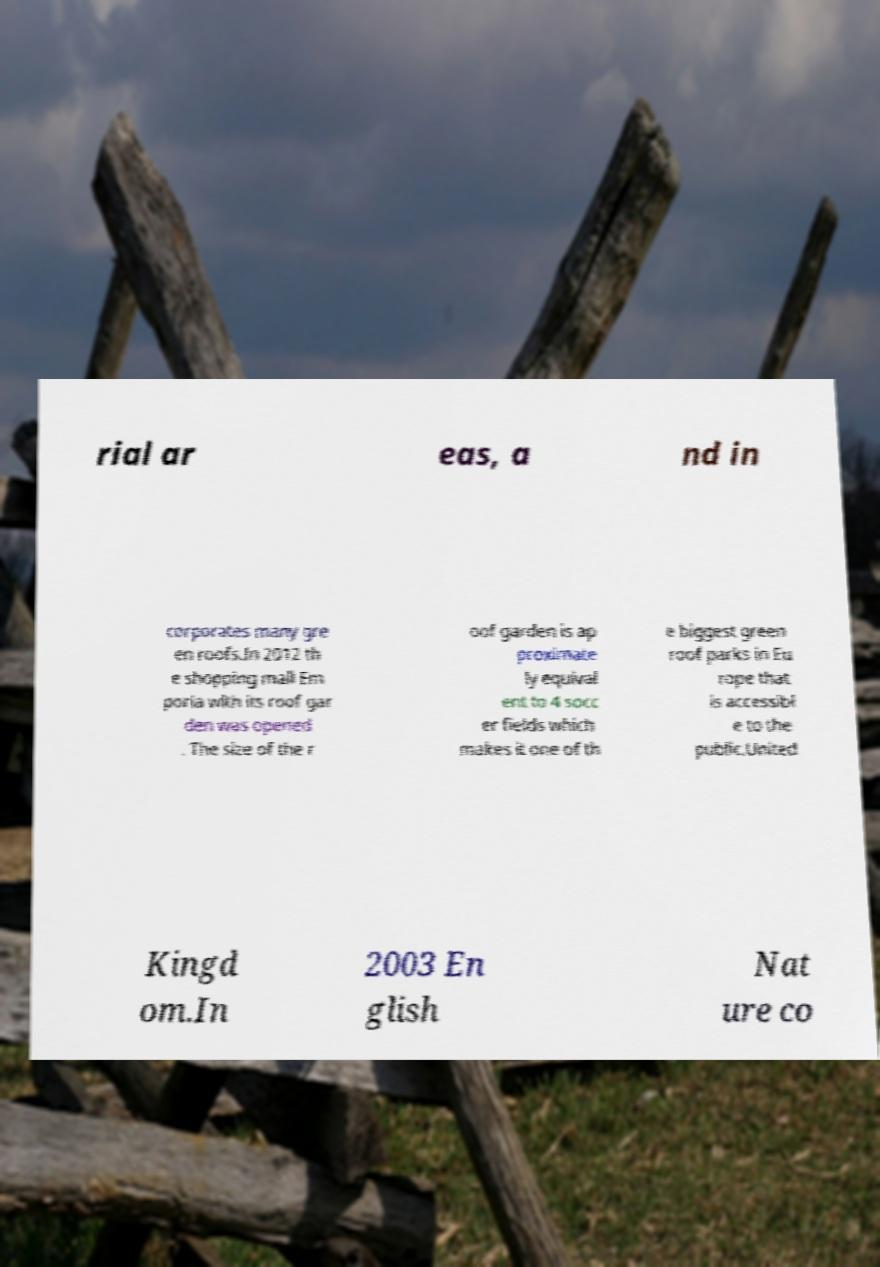Can you read and provide the text displayed in the image?This photo seems to have some interesting text. Can you extract and type it out for me? rial ar eas, a nd in corporates many gre en roofs.In 2012 th e shopping mall Em poria with its roof gar den was opened . The size of the r oof garden is ap proximate ly equival ent to 4 socc er fields which makes it one of th e biggest green roof parks in Eu rope that is accessibl e to the public.United Kingd om.In 2003 En glish Nat ure co 